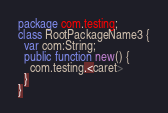Convert code to text. <code><loc_0><loc_0><loc_500><loc_500><_Haxe_>package com.testing;
class RootPackageName3 {
  var com:String;
  public function new() {
    com.testing.<caret>
  }
}</code> 